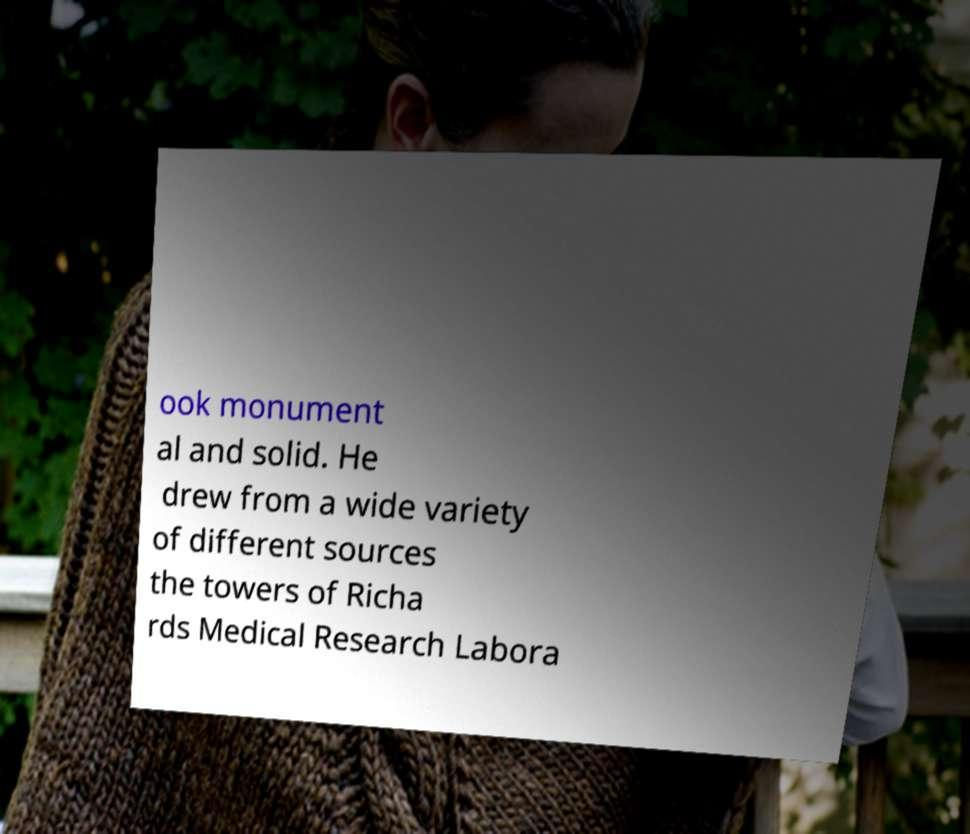I need the written content from this picture converted into text. Can you do that? ook monument al and solid. He drew from a wide variety of different sources the towers of Richa rds Medical Research Labora 